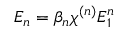Convert formula to latex. <formula><loc_0><loc_0><loc_500><loc_500>E _ { n } = \beta _ { n } { \chi ^ { ( n ) } } E _ { 1 } ^ { n }</formula> 